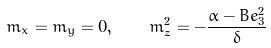<formula> <loc_0><loc_0><loc_500><loc_500>m _ { x } = m _ { y } = 0 , \quad m _ { z } ^ { 2 } = - \frac { \alpha - B e _ { 3 } ^ { 2 } } { \delta }</formula> 